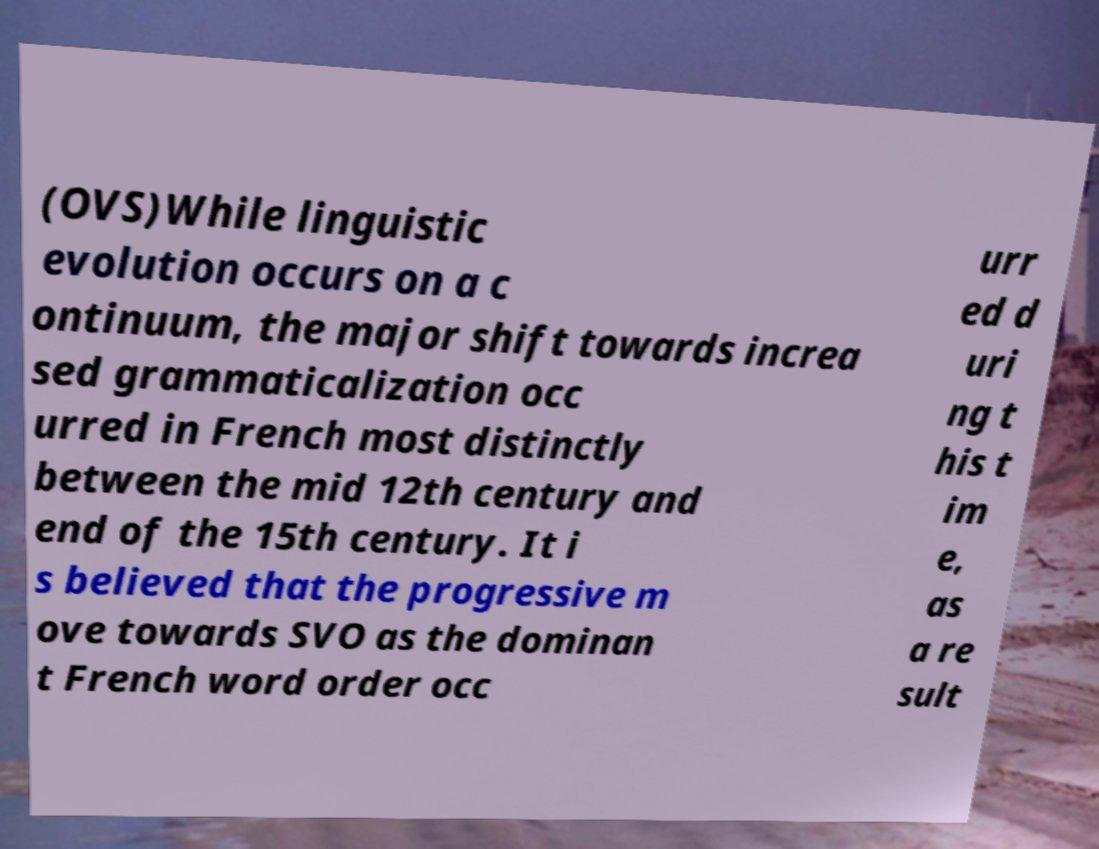Could you assist in decoding the text presented in this image and type it out clearly? (OVS)While linguistic evolution occurs on a c ontinuum, the major shift towards increa sed grammaticalization occ urred in French most distinctly between the mid 12th century and end of the 15th century. It i s believed that the progressive m ove towards SVO as the dominan t French word order occ urr ed d uri ng t his t im e, as a re sult 